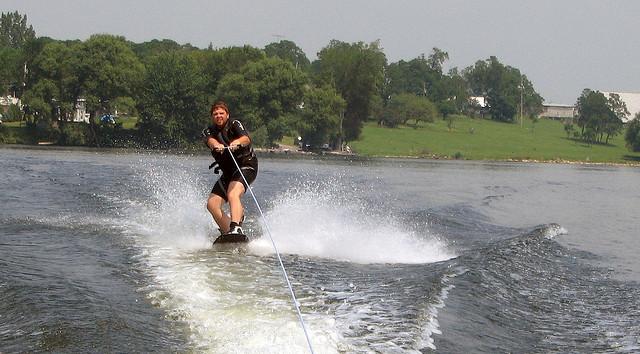What is found behind the trees in the picture?
Quick response, please. House. Is the guy holding onto something?
Answer briefly. Yes. Is he on jet skis?
Keep it brief. No. 